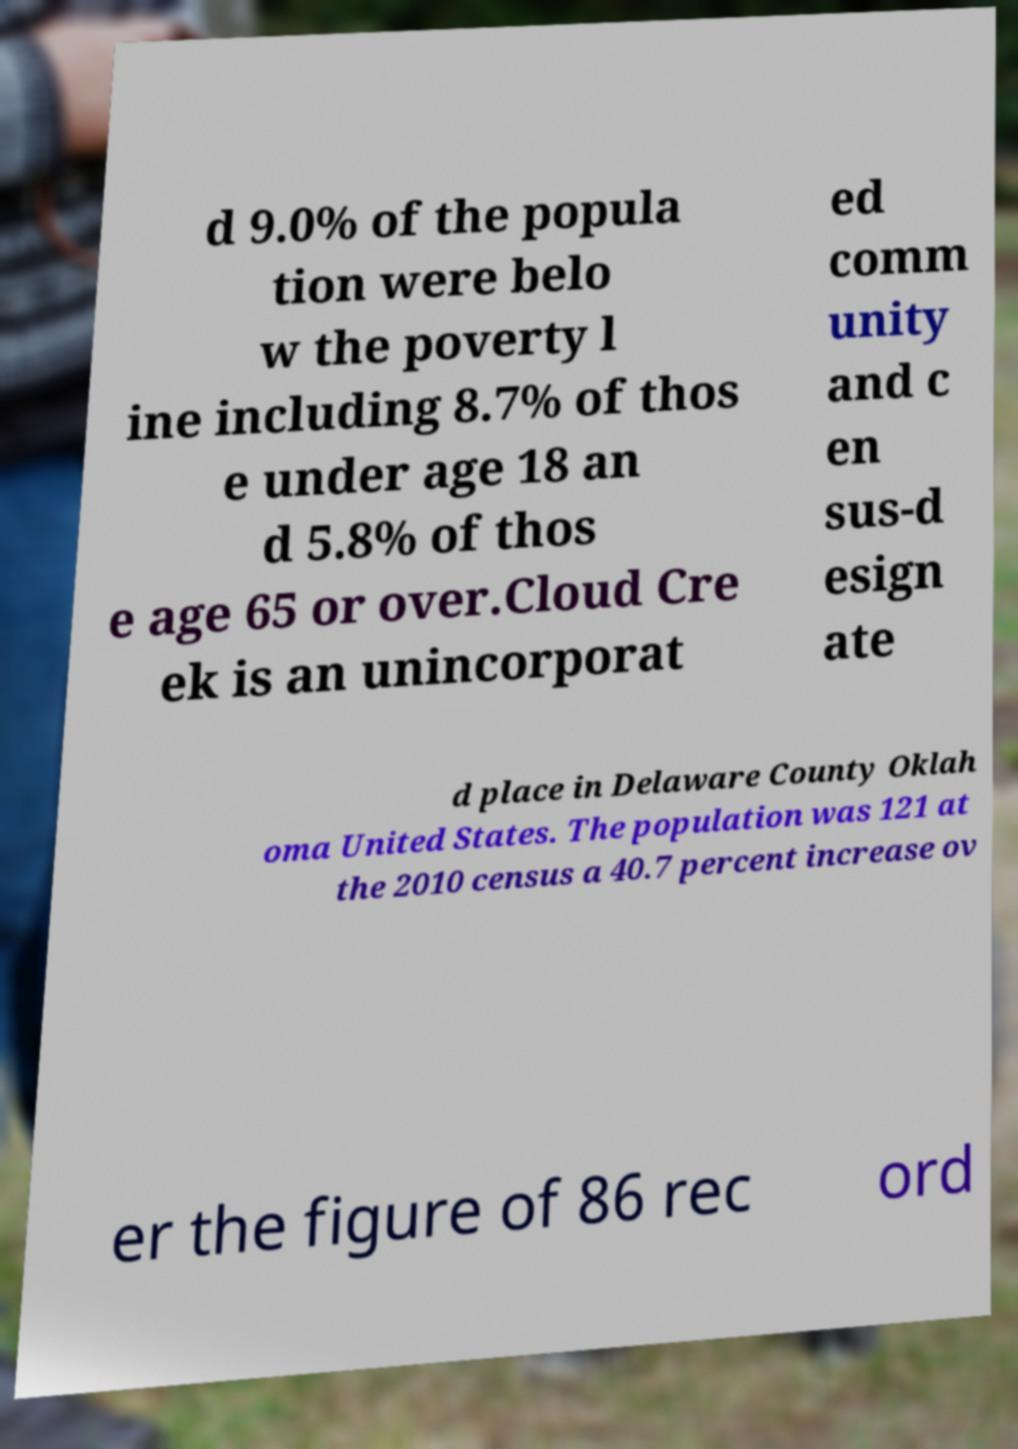For documentation purposes, I need the text within this image transcribed. Could you provide that? d 9.0% of the popula tion were belo w the poverty l ine including 8.7% of thos e under age 18 an d 5.8% of thos e age 65 or over.Cloud Cre ek is an unincorporat ed comm unity and c en sus-d esign ate d place in Delaware County Oklah oma United States. The population was 121 at the 2010 census a 40.7 percent increase ov er the figure of 86 rec ord 